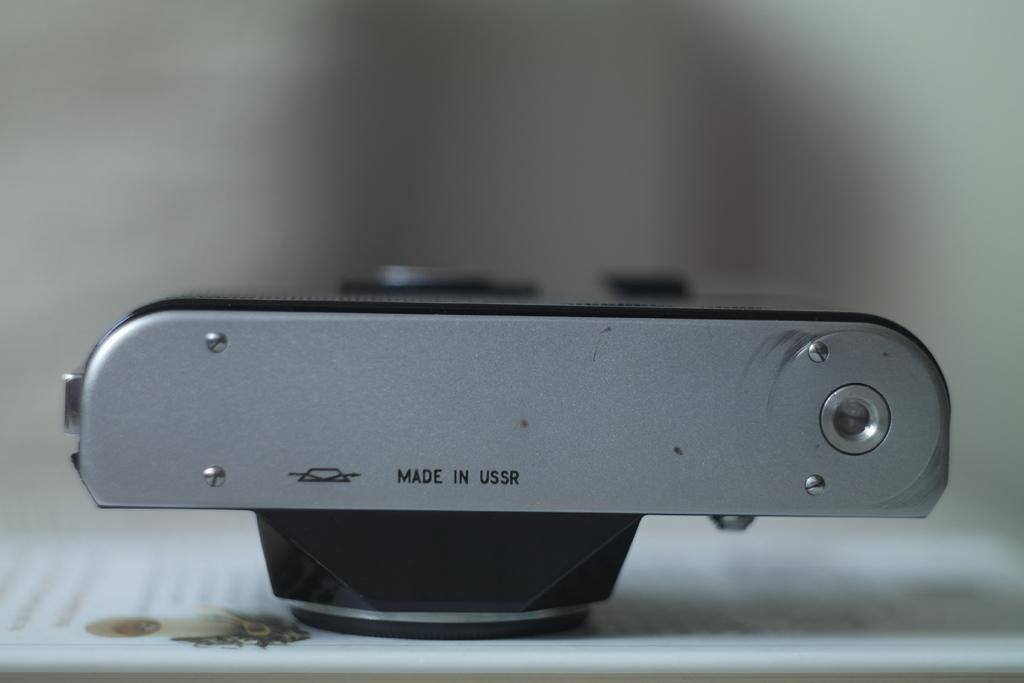What object is the main subject of the image? There is a camera in the image. What feature can be seen on the camera? There is text on the camera. Can you see the turkey's face in the image? There is no turkey or face present in the image; it features a camera with text on it. 